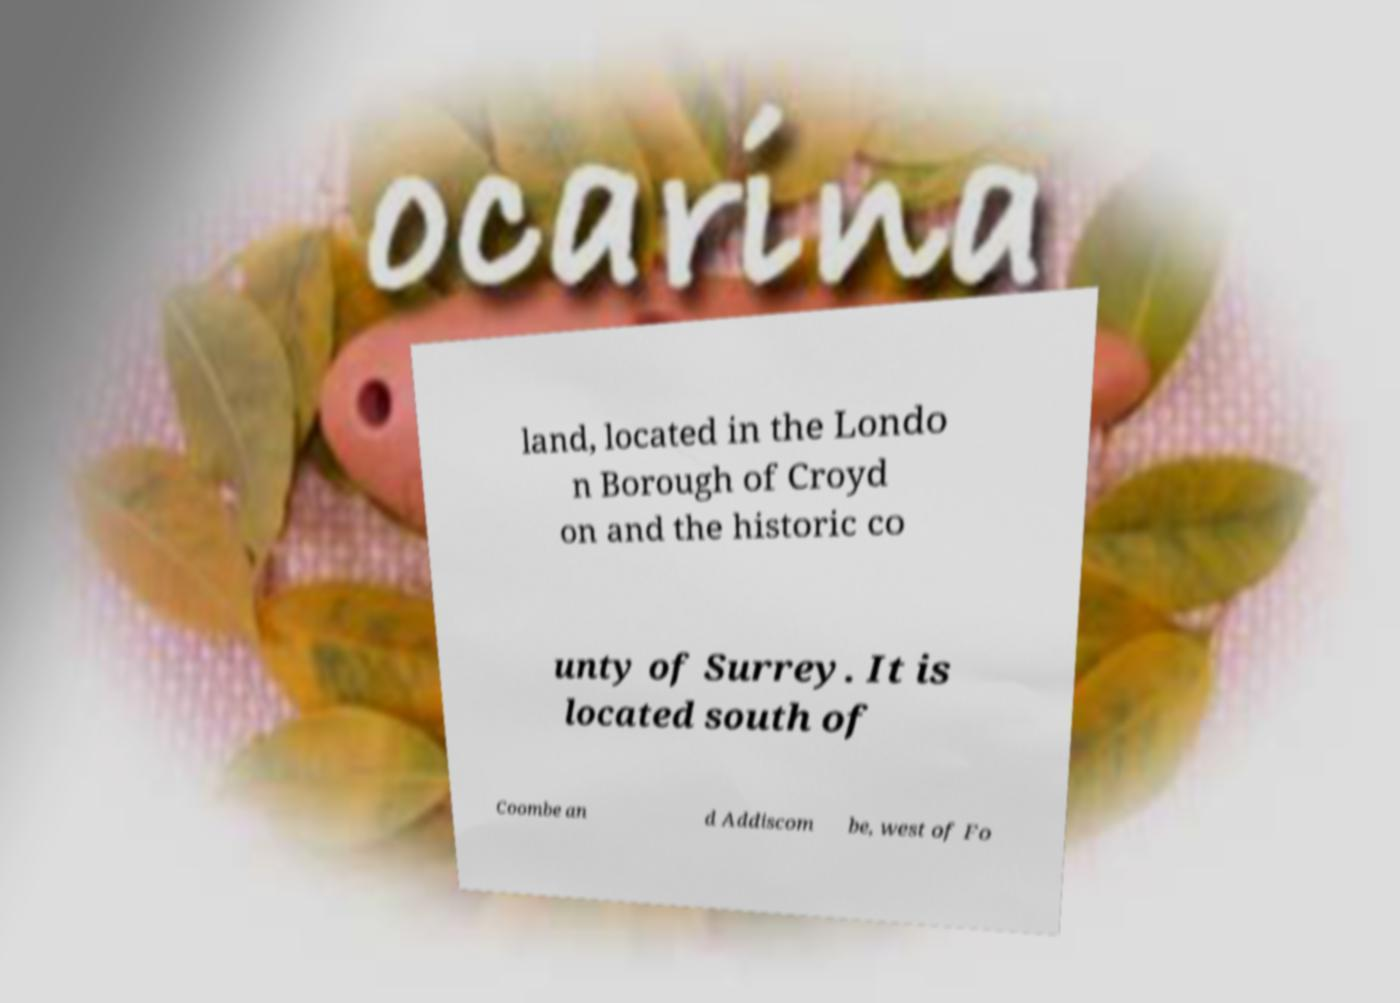I need the written content from this picture converted into text. Can you do that? land, located in the Londo n Borough of Croyd on and the historic co unty of Surrey. It is located south of Coombe an d Addiscom be, west of Fo 